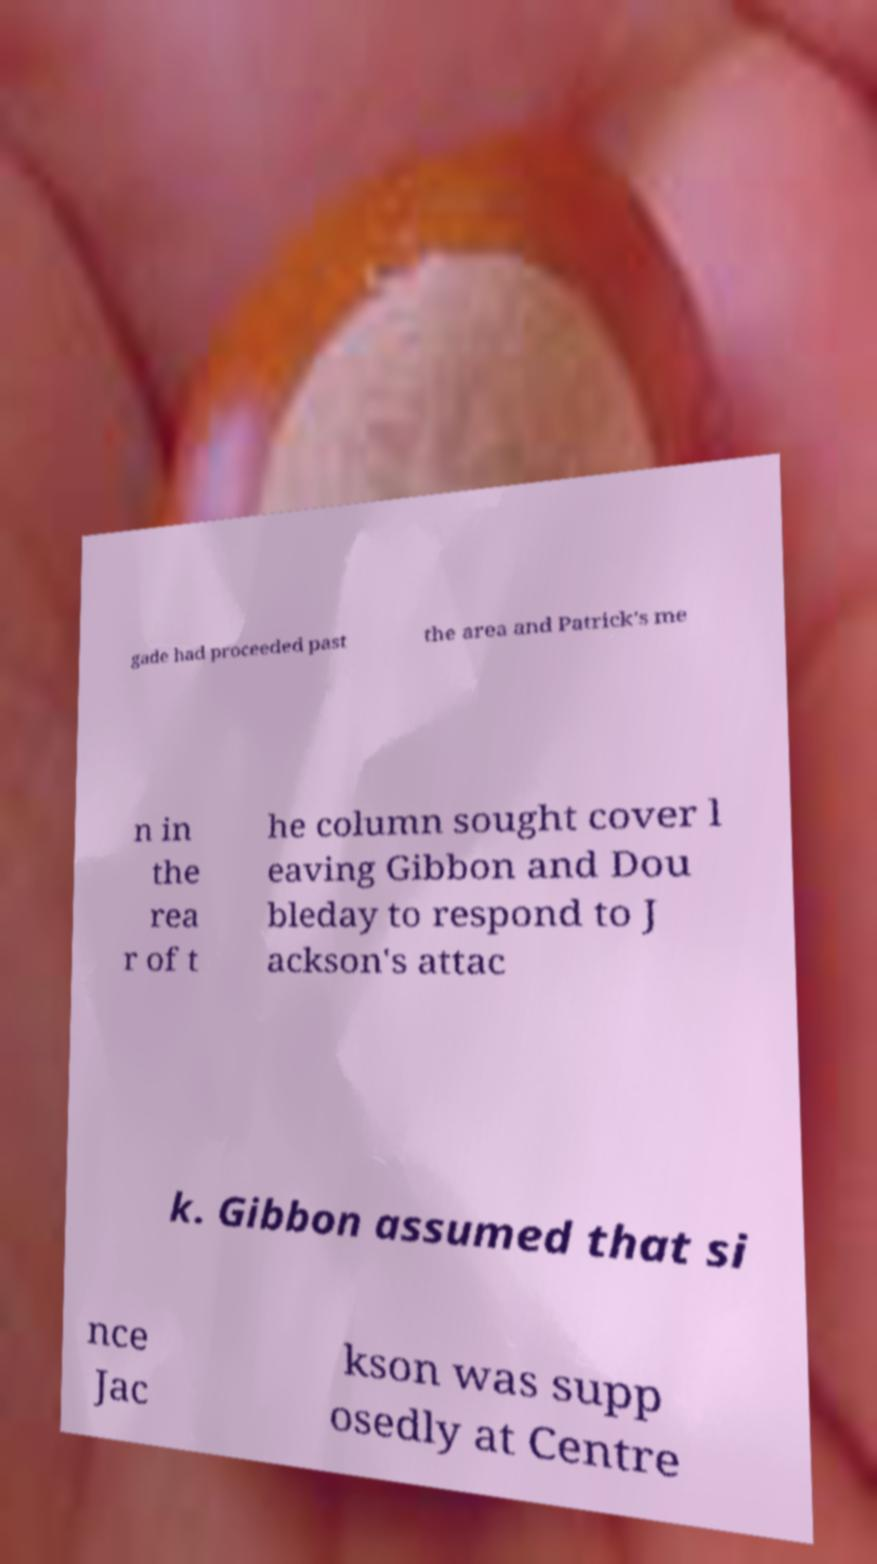There's text embedded in this image that I need extracted. Can you transcribe it verbatim? gade had proceeded past the area and Patrick's me n in the rea r of t he column sought cover l eaving Gibbon and Dou bleday to respond to J ackson's attac k. Gibbon assumed that si nce Jac kson was supp osedly at Centre 